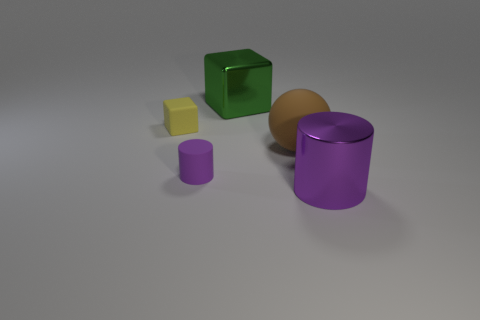Subtract 1 cylinders. How many cylinders are left? 1 Add 2 big objects. How many objects exist? 7 Subtract all blocks. How many objects are left? 3 Subtract 0 purple spheres. How many objects are left? 5 Subtract all green cylinders. Subtract all red cubes. How many cylinders are left? 2 Subtract all purple cylinders. How many yellow cubes are left? 1 Subtract all large green things. Subtract all green cubes. How many objects are left? 3 Add 2 matte cylinders. How many matte cylinders are left? 3 Add 4 small objects. How many small objects exist? 6 Subtract all yellow cubes. How many cubes are left? 1 